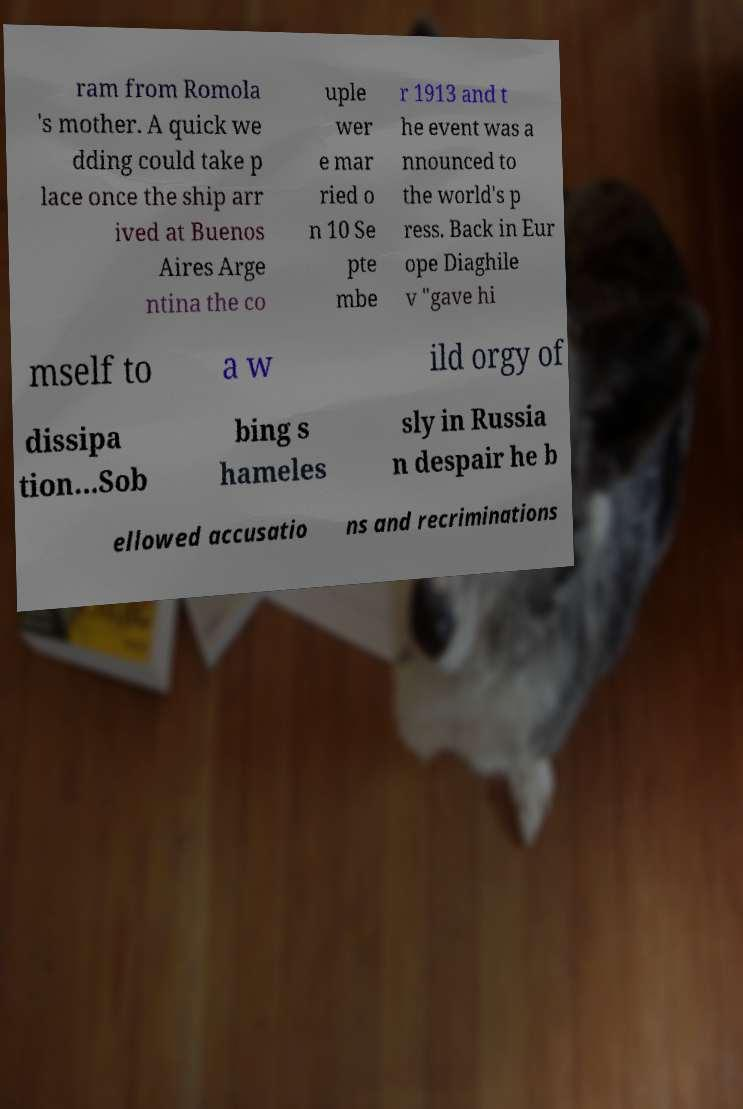Could you extract and type out the text from this image? ram from Romola 's mother. A quick we dding could take p lace once the ship arr ived at Buenos Aires Arge ntina the co uple wer e mar ried o n 10 Se pte mbe r 1913 and t he event was a nnounced to the world's p ress. Back in Eur ope Diaghile v "gave hi mself to a w ild orgy of dissipa tion...Sob bing s hameles sly in Russia n despair he b ellowed accusatio ns and recriminations 